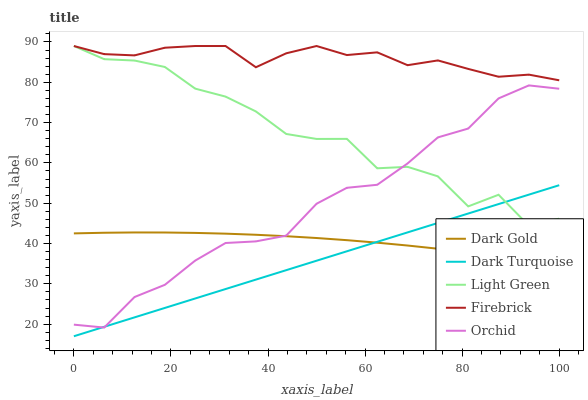Does Dark Turquoise have the minimum area under the curve?
Answer yes or no. Yes. Does Firebrick have the maximum area under the curve?
Answer yes or no. Yes. Does Orchid have the minimum area under the curve?
Answer yes or no. No. Does Orchid have the maximum area under the curve?
Answer yes or no. No. Is Dark Turquoise the smoothest?
Answer yes or no. Yes. Is Light Green the roughest?
Answer yes or no. Yes. Is Firebrick the smoothest?
Answer yes or no. No. Is Firebrick the roughest?
Answer yes or no. No. Does Dark Turquoise have the lowest value?
Answer yes or no. Yes. Does Orchid have the lowest value?
Answer yes or no. No. Does Light Green have the highest value?
Answer yes or no. Yes. Does Orchid have the highest value?
Answer yes or no. No. Is Dark Gold less than Light Green?
Answer yes or no. Yes. Is Firebrick greater than Dark Turquoise?
Answer yes or no. Yes. Does Light Green intersect Dark Turquoise?
Answer yes or no. Yes. Is Light Green less than Dark Turquoise?
Answer yes or no. No. Is Light Green greater than Dark Turquoise?
Answer yes or no. No. Does Dark Gold intersect Light Green?
Answer yes or no. No. 